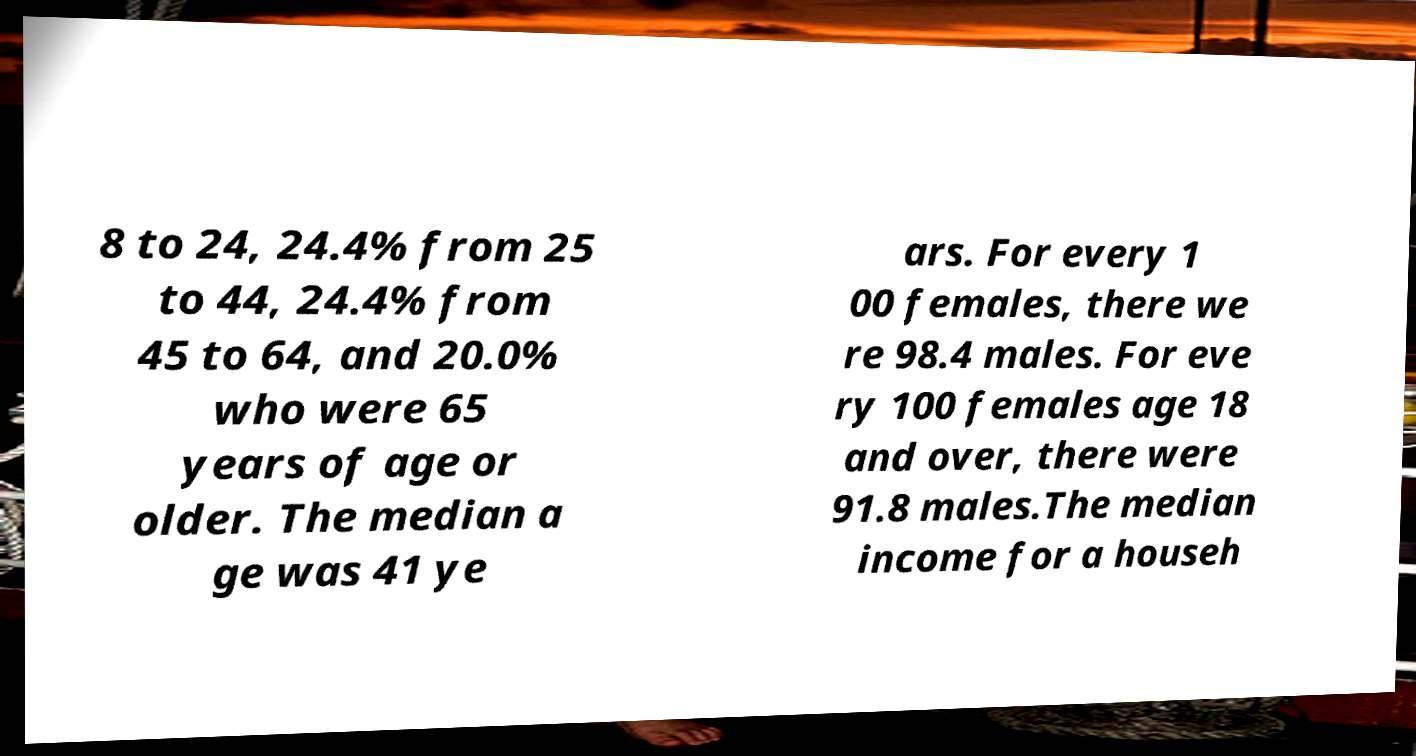Can you read and provide the text displayed in the image?This photo seems to have some interesting text. Can you extract and type it out for me? 8 to 24, 24.4% from 25 to 44, 24.4% from 45 to 64, and 20.0% who were 65 years of age or older. The median a ge was 41 ye ars. For every 1 00 females, there we re 98.4 males. For eve ry 100 females age 18 and over, there were 91.8 males.The median income for a househ 